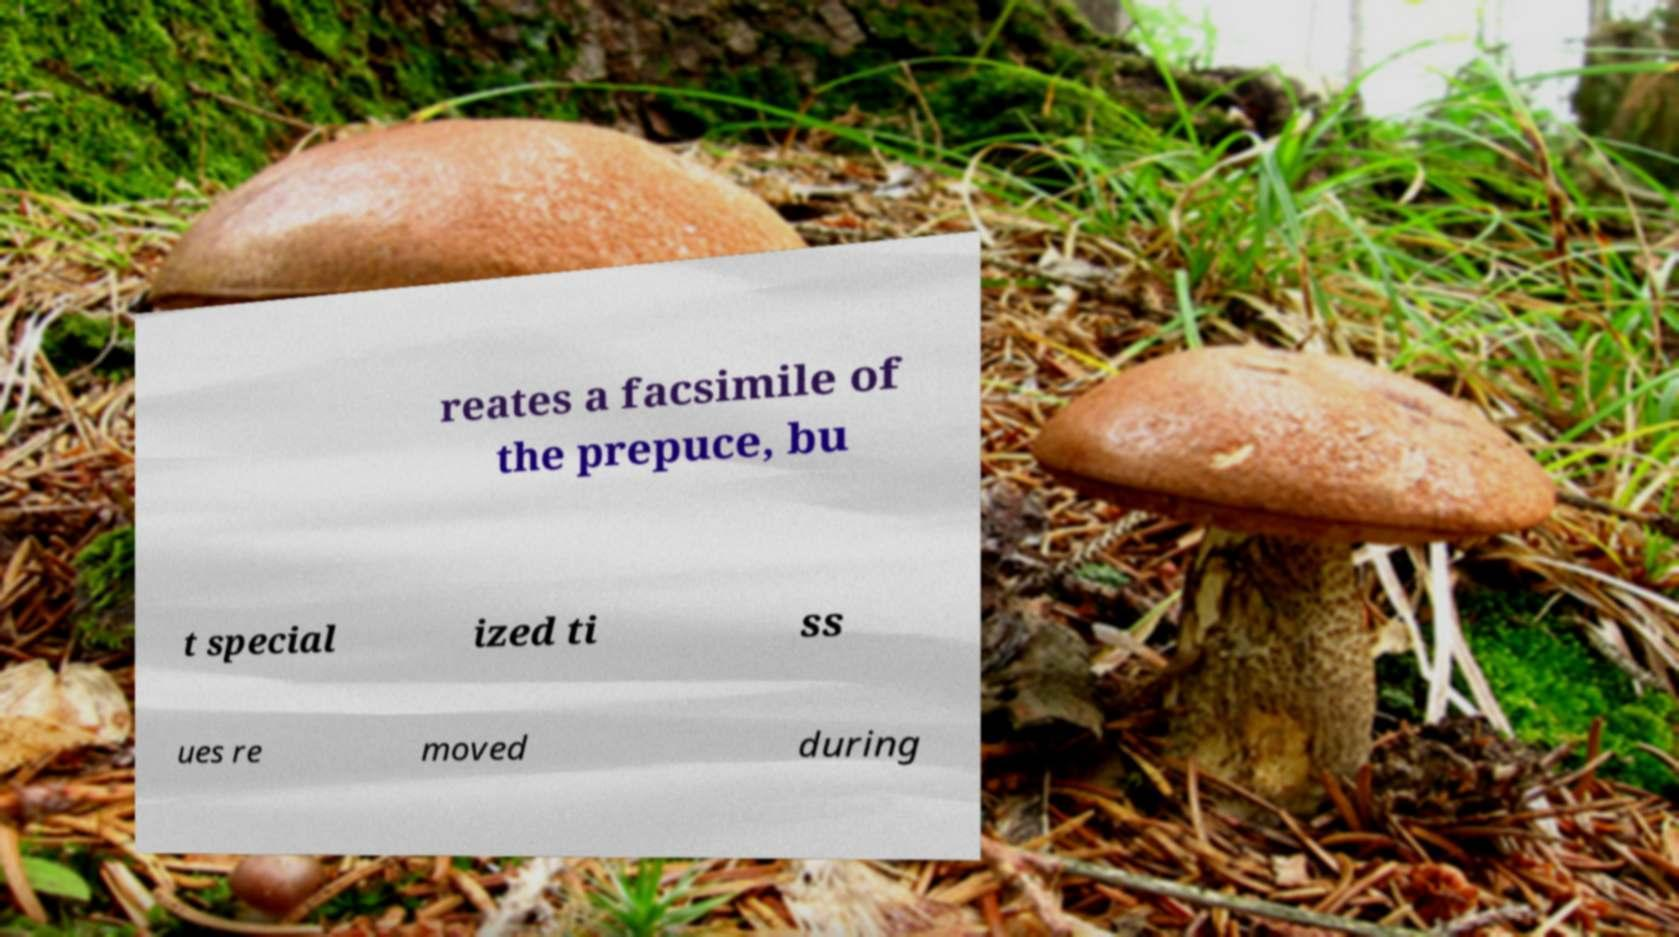Could you extract and type out the text from this image? reates a facsimile of the prepuce, bu t special ized ti ss ues re moved during 